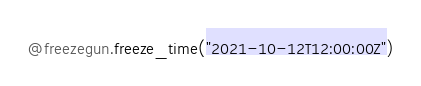Convert code to text. <code><loc_0><loc_0><loc_500><loc_500><_Python_>@freezegun.freeze_time("2021-10-12T12:00:00Z")</code> 